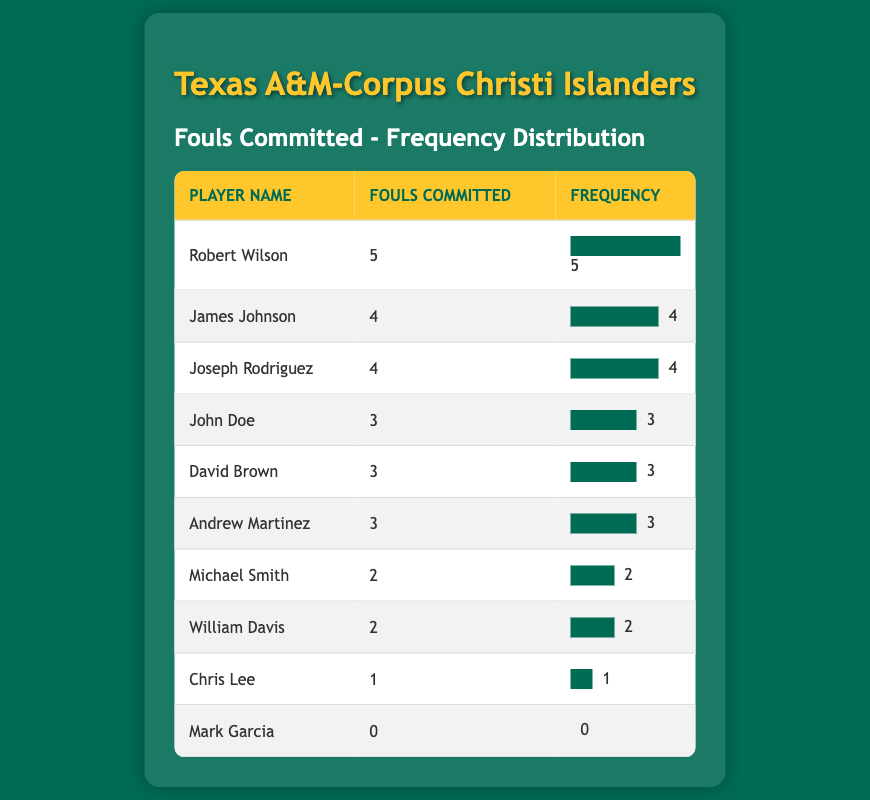What is the maximum number of fouls committed by a player? The table shows that the player with the highest number of fouls is Robert Wilson, who committed 5 fouls.
Answer: 5 Which player committed the least number of fouls? By scanning the "Fouls Committed" column, Mark Garcia is noted to have committed 0 fouls, which is the least.
Answer: Mark Garcia How many players committed 3 fouls? Three players are listed with 3 fouls: John Doe, David Brown, and Andrew Martinez.
Answer: 3 What is the average number of fouls committed by all players? To find the average, we sum the fouls (5 + 4 + 4 + 3 + 3 + 3 + 2 + 2 + 1 + 0 = 23) and divide by the number of players (10), which gives an average of 2.3.
Answer: 2.3 Did any player commit more than 4 fouls? Yes, Robert Wilson and Joseph Rodriguez both committed more than 4 fouls (5 and 4 respectively).
Answer: Yes What is the total number of fouls committed by all players combined? Adding the fouls together gives us 23 (5 + 4 + 4 + 3 + 3 + 3 + 2 + 2 + 1 + 0 = 23).
Answer: 23 Which player(s) committed fouls 2 or less? The players who committed 2 or fewer fouls are Chris Lee (1 foul) and Mark Garcia (0 fouls).
Answer: Chris Lee and Mark Garcia How many players committed 4 fouls or more? There are 3 players who committed 4 fouls or more: Robert Wilson (5), James Johnson (4), and Joseph Rodriguez (4).
Answer: 3 What is the range of fouls committed in this table? The highest number of fouls is 5 (by Robert Wilson) and the lowest is 0 (by Mark Garcia), so the range is 5 - 0 = 5.
Answer: 5 